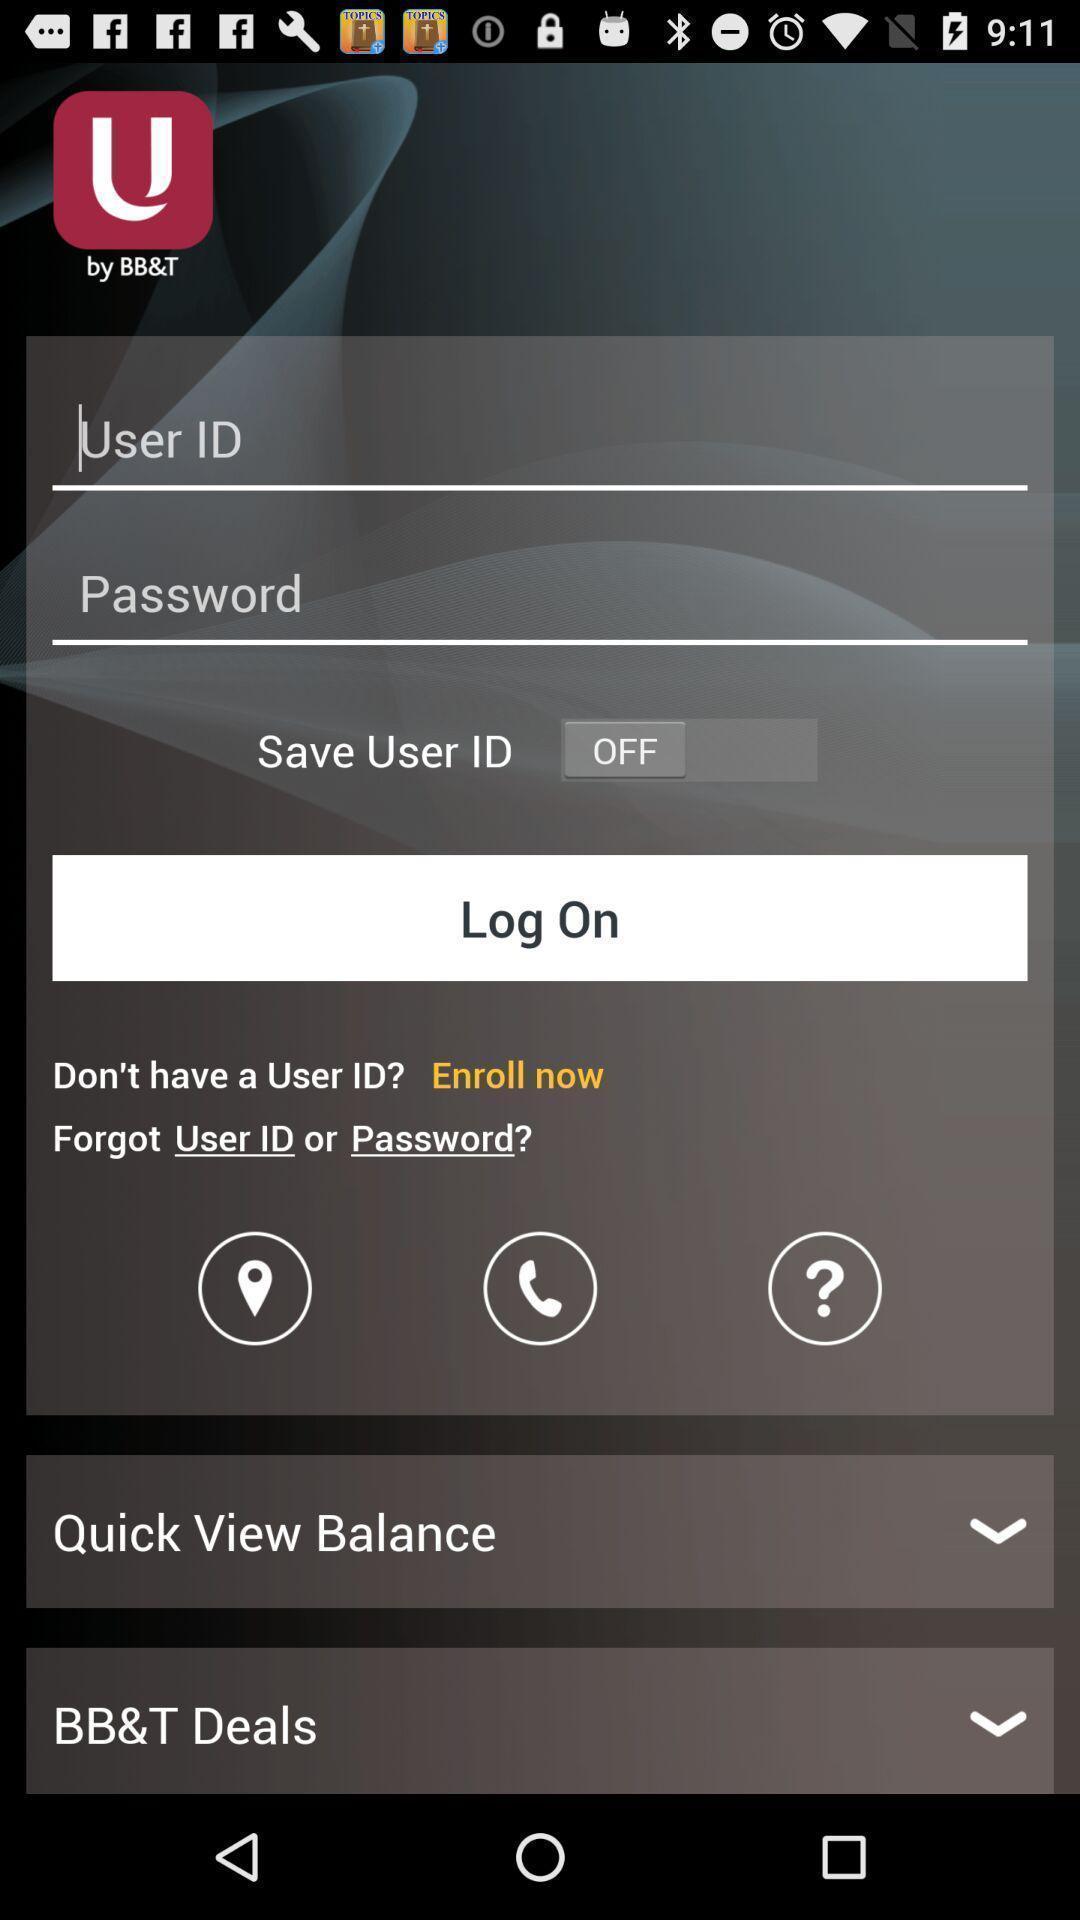What details can you identify in this image? Page showing logon option. 